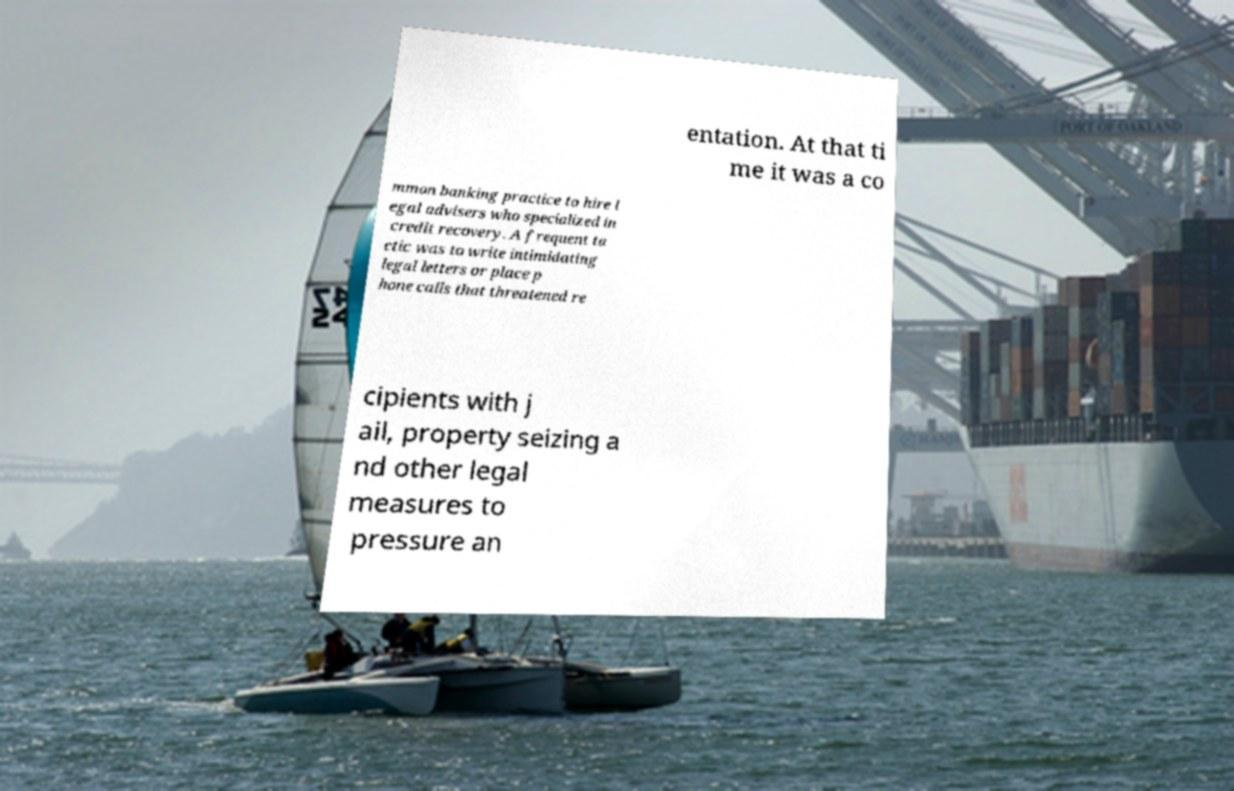There's text embedded in this image that I need extracted. Can you transcribe it verbatim? entation. At that ti me it was a co mmon banking practice to hire l egal advisers who specialized in credit recovery. A frequent ta ctic was to write intimidating legal letters or place p hone calls that threatened re cipients with j ail, property seizing a nd other legal measures to pressure an 